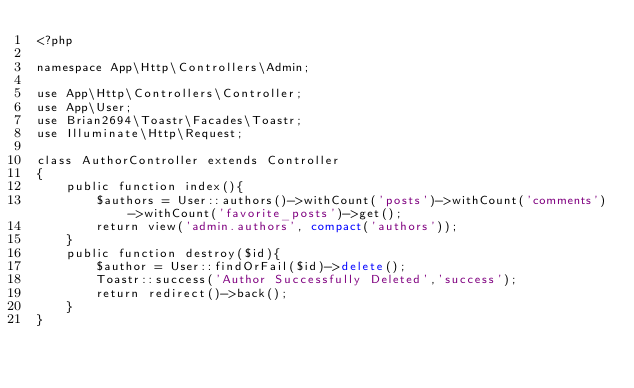<code> <loc_0><loc_0><loc_500><loc_500><_PHP_><?php

namespace App\Http\Controllers\Admin;

use App\Http\Controllers\Controller;
use App\User;
use Brian2694\Toastr\Facades\Toastr;
use Illuminate\Http\Request;

class AuthorController extends Controller
{
    public function index(){
        $authors = User::authors()->withCount('posts')->withCount('comments')->withCount('favorite_posts')->get();
        return view('admin.authors', compact('authors'));
    }
    public function destroy($id){
        $author = User::findOrFail($id)->delete();
        Toastr::success('Author Successfully Deleted','success');
        return redirect()->back();
    }
}
</code> 